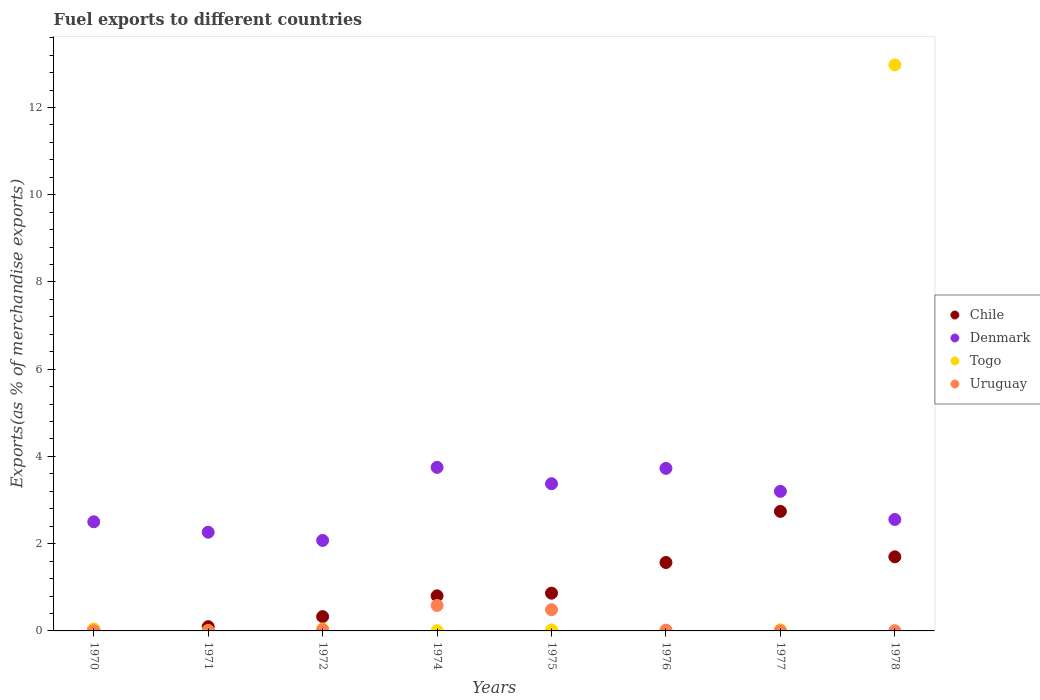How many different coloured dotlines are there?
Provide a succinct answer. 4. Is the number of dotlines equal to the number of legend labels?
Offer a terse response. Yes. What is the percentage of exports to different countries in Chile in 1977?
Offer a very short reply. 2.74. Across all years, what is the maximum percentage of exports to different countries in Chile?
Your response must be concise. 2.74. Across all years, what is the minimum percentage of exports to different countries in Togo?
Ensure brevity in your answer.  0. In which year was the percentage of exports to different countries in Uruguay maximum?
Offer a terse response. 1974. In which year was the percentage of exports to different countries in Chile minimum?
Give a very brief answer. 1970. What is the total percentage of exports to different countries in Togo in the graph?
Ensure brevity in your answer.  13.13. What is the difference between the percentage of exports to different countries in Uruguay in 1970 and that in 1971?
Offer a very short reply. -0. What is the difference between the percentage of exports to different countries in Denmark in 1971 and the percentage of exports to different countries in Togo in 1970?
Provide a short and direct response. 2.22. What is the average percentage of exports to different countries in Togo per year?
Make the answer very short. 1.64. In the year 1978, what is the difference between the percentage of exports to different countries in Chile and percentage of exports to different countries in Denmark?
Provide a succinct answer. -0.86. In how many years, is the percentage of exports to different countries in Denmark greater than 4 %?
Provide a succinct answer. 0. What is the ratio of the percentage of exports to different countries in Chile in 1971 to that in 1975?
Provide a short and direct response. 0.11. Is the percentage of exports to different countries in Togo in 1971 less than that in 1978?
Keep it short and to the point. Yes. Is the difference between the percentage of exports to different countries in Chile in 1970 and 1977 greater than the difference between the percentage of exports to different countries in Denmark in 1970 and 1977?
Make the answer very short. No. What is the difference between the highest and the second highest percentage of exports to different countries in Chile?
Ensure brevity in your answer.  1.04. What is the difference between the highest and the lowest percentage of exports to different countries in Chile?
Provide a short and direct response. 2.71. In how many years, is the percentage of exports to different countries in Denmark greater than the average percentage of exports to different countries in Denmark taken over all years?
Give a very brief answer. 4. Is it the case that in every year, the sum of the percentage of exports to different countries in Togo and percentage of exports to different countries in Uruguay  is greater than the sum of percentage of exports to different countries in Chile and percentage of exports to different countries in Denmark?
Provide a succinct answer. No. Does the percentage of exports to different countries in Denmark monotonically increase over the years?
Offer a very short reply. No. Is the percentage of exports to different countries in Togo strictly greater than the percentage of exports to different countries in Uruguay over the years?
Offer a very short reply. No. How many years are there in the graph?
Your answer should be compact. 8. Are the values on the major ticks of Y-axis written in scientific E-notation?
Provide a short and direct response. No. Does the graph contain grids?
Provide a succinct answer. No. How are the legend labels stacked?
Your answer should be very brief. Vertical. What is the title of the graph?
Offer a very short reply. Fuel exports to different countries. Does "Thailand" appear as one of the legend labels in the graph?
Keep it short and to the point. No. What is the label or title of the X-axis?
Offer a terse response. Years. What is the label or title of the Y-axis?
Your answer should be very brief. Exports(as % of merchandise exports). What is the Exports(as % of merchandise exports) in Chile in 1970?
Your response must be concise. 0.03. What is the Exports(as % of merchandise exports) of Denmark in 1970?
Offer a very short reply. 2.5. What is the Exports(as % of merchandise exports) in Togo in 1970?
Make the answer very short. 0.04. What is the Exports(as % of merchandise exports) in Uruguay in 1970?
Provide a short and direct response. 0. What is the Exports(as % of merchandise exports) in Chile in 1971?
Provide a succinct answer. 0.1. What is the Exports(as % of merchandise exports) of Denmark in 1971?
Your response must be concise. 2.26. What is the Exports(as % of merchandise exports) of Togo in 1971?
Keep it short and to the point. 0.01. What is the Exports(as % of merchandise exports) in Uruguay in 1971?
Your response must be concise. 0.01. What is the Exports(as % of merchandise exports) of Chile in 1972?
Keep it short and to the point. 0.33. What is the Exports(as % of merchandise exports) in Denmark in 1972?
Offer a very short reply. 2.07. What is the Exports(as % of merchandise exports) in Togo in 1972?
Provide a short and direct response. 0.05. What is the Exports(as % of merchandise exports) of Uruguay in 1972?
Ensure brevity in your answer.  0.03. What is the Exports(as % of merchandise exports) in Chile in 1974?
Give a very brief answer. 0.8. What is the Exports(as % of merchandise exports) in Denmark in 1974?
Offer a terse response. 3.75. What is the Exports(as % of merchandise exports) of Togo in 1974?
Offer a terse response. 0. What is the Exports(as % of merchandise exports) of Uruguay in 1974?
Provide a short and direct response. 0.58. What is the Exports(as % of merchandise exports) in Chile in 1975?
Offer a very short reply. 0.87. What is the Exports(as % of merchandise exports) of Denmark in 1975?
Provide a short and direct response. 3.37. What is the Exports(as % of merchandise exports) of Togo in 1975?
Offer a terse response. 0.02. What is the Exports(as % of merchandise exports) of Uruguay in 1975?
Make the answer very short. 0.49. What is the Exports(as % of merchandise exports) of Chile in 1976?
Provide a succinct answer. 1.57. What is the Exports(as % of merchandise exports) in Denmark in 1976?
Your response must be concise. 3.73. What is the Exports(as % of merchandise exports) in Togo in 1976?
Make the answer very short. 0. What is the Exports(as % of merchandise exports) of Uruguay in 1976?
Your answer should be compact. 0.02. What is the Exports(as % of merchandise exports) in Chile in 1977?
Offer a very short reply. 2.74. What is the Exports(as % of merchandise exports) of Denmark in 1977?
Ensure brevity in your answer.  3.2. What is the Exports(as % of merchandise exports) in Togo in 1977?
Keep it short and to the point. 0.03. What is the Exports(as % of merchandise exports) in Uruguay in 1977?
Make the answer very short. 0. What is the Exports(as % of merchandise exports) in Chile in 1978?
Offer a very short reply. 1.7. What is the Exports(as % of merchandise exports) of Denmark in 1978?
Keep it short and to the point. 2.56. What is the Exports(as % of merchandise exports) in Togo in 1978?
Make the answer very short. 12.98. What is the Exports(as % of merchandise exports) in Uruguay in 1978?
Keep it short and to the point. 0. Across all years, what is the maximum Exports(as % of merchandise exports) of Chile?
Give a very brief answer. 2.74. Across all years, what is the maximum Exports(as % of merchandise exports) in Denmark?
Ensure brevity in your answer.  3.75. Across all years, what is the maximum Exports(as % of merchandise exports) of Togo?
Your response must be concise. 12.98. Across all years, what is the maximum Exports(as % of merchandise exports) in Uruguay?
Offer a terse response. 0.58. Across all years, what is the minimum Exports(as % of merchandise exports) in Chile?
Your answer should be compact. 0.03. Across all years, what is the minimum Exports(as % of merchandise exports) of Denmark?
Give a very brief answer. 2.07. Across all years, what is the minimum Exports(as % of merchandise exports) of Togo?
Offer a very short reply. 0. Across all years, what is the minimum Exports(as % of merchandise exports) in Uruguay?
Give a very brief answer. 0. What is the total Exports(as % of merchandise exports) in Chile in the graph?
Offer a terse response. 8.14. What is the total Exports(as % of merchandise exports) in Denmark in the graph?
Offer a terse response. 23.45. What is the total Exports(as % of merchandise exports) of Togo in the graph?
Offer a terse response. 13.13. What is the total Exports(as % of merchandise exports) of Uruguay in the graph?
Your response must be concise. 1.13. What is the difference between the Exports(as % of merchandise exports) in Chile in 1970 and that in 1971?
Ensure brevity in your answer.  -0.06. What is the difference between the Exports(as % of merchandise exports) in Denmark in 1970 and that in 1971?
Provide a succinct answer. 0.24. What is the difference between the Exports(as % of merchandise exports) in Togo in 1970 and that in 1971?
Provide a succinct answer. 0.03. What is the difference between the Exports(as % of merchandise exports) in Uruguay in 1970 and that in 1971?
Ensure brevity in your answer.  -0. What is the difference between the Exports(as % of merchandise exports) in Chile in 1970 and that in 1972?
Offer a terse response. -0.29. What is the difference between the Exports(as % of merchandise exports) in Denmark in 1970 and that in 1972?
Your response must be concise. 0.43. What is the difference between the Exports(as % of merchandise exports) of Togo in 1970 and that in 1972?
Provide a short and direct response. -0. What is the difference between the Exports(as % of merchandise exports) in Uruguay in 1970 and that in 1972?
Offer a very short reply. -0.03. What is the difference between the Exports(as % of merchandise exports) in Chile in 1970 and that in 1974?
Offer a very short reply. -0.77. What is the difference between the Exports(as % of merchandise exports) in Denmark in 1970 and that in 1974?
Your answer should be compact. -1.25. What is the difference between the Exports(as % of merchandise exports) of Togo in 1970 and that in 1974?
Offer a very short reply. 0.04. What is the difference between the Exports(as % of merchandise exports) in Uruguay in 1970 and that in 1974?
Your answer should be very brief. -0.58. What is the difference between the Exports(as % of merchandise exports) in Chile in 1970 and that in 1975?
Your response must be concise. -0.83. What is the difference between the Exports(as % of merchandise exports) in Denmark in 1970 and that in 1975?
Keep it short and to the point. -0.87. What is the difference between the Exports(as % of merchandise exports) of Togo in 1970 and that in 1975?
Make the answer very short. 0.02. What is the difference between the Exports(as % of merchandise exports) of Uruguay in 1970 and that in 1975?
Keep it short and to the point. -0.48. What is the difference between the Exports(as % of merchandise exports) of Chile in 1970 and that in 1976?
Ensure brevity in your answer.  -1.53. What is the difference between the Exports(as % of merchandise exports) of Denmark in 1970 and that in 1976?
Offer a terse response. -1.22. What is the difference between the Exports(as % of merchandise exports) of Togo in 1970 and that in 1976?
Keep it short and to the point. 0.04. What is the difference between the Exports(as % of merchandise exports) in Uruguay in 1970 and that in 1976?
Your answer should be compact. -0.02. What is the difference between the Exports(as % of merchandise exports) of Chile in 1970 and that in 1977?
Provide a short and direct response. -2.71. What is the difference between the Exports(as % of merchandise exports) of Denmark in 1970 and that in 1977?
Offer a very short reply. -0.7. What is the difference between the Exports(as % of merchandise exports) of Togo in 1970 and that in 1977?
Keep it short and to the point. 0.02. What is the difference between the Exports(as % of merchandise exports) in Uruguay in 1970 and that in 1977?
Your answer should be very brief. -0. What is the difference between the Exports(as % of merchandise exports) in Chile in 1970 and that in 1978?
Offer a terse response. -1.67. What is the difference between the Exports(as % of merchandise exports) of Denmark in 1970 and that in 1978?
Offer a very short reply. -0.05. What is the difference between the Exports(as % of merchandise exports) in Togo in 1970 and that in 1978?
Keep it short and to the point. -12.93. What is the difference between the Exports(as % of merchandise exports) in Uruguay in 1970 and that in 1978?
Keep it short and to the point. -0. What is the difference between the Exports(as % of merchandise exports) of Chile in 1971 and that in 1972?
Your response must be concise. -0.23. What is the difference between the Exports(as % of merchandise exports) of Denmark in 1971 and that in 1972?
Offer a very short reply. 0.19. What is the difference between the Exports(as % of merchandise exports) of Togo in 1971 and that in 1972?
Provide a short and direct response. -0.04. What is the difference between the Exports(as % of merchandise exports) in Uruguay in 1971 and that in 1972?
Provide a succinct answer. -0.02. What is the difference between the Exports(as % of merchandise exports) in Chile in 1971 and that in 1974?
Keep it short and to the point. -0.71. What is the difference between the Exports(as % of merchandise exports) of Denmark in 1971 and that in 1974?
Make the answer very short. -1.49. What is the difference between the Exports(as % of merchandise exports) of Togo in 1971 and that in 1974?
Offer a terse response. 0. What is the difference between the Exports(as % of merchandise exports) of Uruguay in 1971 and that in 1974?
Your response must be concise. -0.58. What is the difference between the Exports(as % of merchandise exports) of Chile in 1971 and that in 1975?
Offer a very short reply. -0.77. What is the difference between the Exports(as % of merchandise exports) in Denmark in 1971 and that in 1975?
Provide a succinct answer. -1.11. What is the difference between the Exports(as % of merchandise exports) in Togo in 1971 and that in 1975?
Ensure brevity in your answer.  -0.01. What is the difference between the Exports(as % of merchandise exports) of Uruguay in 1971 and that in 1975?
Keep it short and to the point. -0.48. What is the difference between the Exports(as % of merchandise exports) in Chile in 1971 and that in 1976?
Ensure brevity in your answer.  -1.47. What is the difference between the Exports(as % of merchandise exports) in Denmark in 1971 and that in 1976?
Offer a terse response. -1.46. What is the difference between the Exports(as % of merchandise exports) of Togo in 1971 and that in 1976?
Provide a succinct answer. 0. What is the difference between the Exports(as % of merchandise exports) in Uruguay in 1971 and that in 1976?
Provide a short and direct response. -0.01. What is the difference between the Exports(as % of merchandise exports) of Chile in 1971 and that in 1977?
Make the answer very short. -2.64. What is the difference between the Exports(as % of merchandise exports) of Denmark in 1971 and that in 1977?
Keep it short and to the point. -0.94. What is the difference between the Exports(as % of merchandise exports) of Togo in 1971 and that in 1977?
Offer a terse response. -0.02. What is the difference between the Exports(as % of merchandise exports) of Uruguay in 1971 and that in 1977?
Offer a terse response. 0. What is the difference between the Exports(as % of merchandise exports) of Chile in 1971 and that in 1978?
Make the answer very short. -1.6. What is the difference between the Exports(as % of merchandise exports) in Denmark in 1971 and that in 1978?
Offer a terse response. -0.29. What is the difference between the Exports(as % of merchandise exports) of Togo in 1971 and that in 1978?
Offer a terse response. -12.97. What is the difference between the Exports(as % of merchandise exports) in Uruguay in 1971 and that in 1978?
Keep it short and to the point. 0. What is the difference between the Exports(as % of merchandise exports) in Chile in 1972 and that in 1974?
Ensure brevity in your answer.  -0.48. What is the difference between the Exports(as % of merchandise exports) of Denmark in 1972 and that in 1974?
Make the answer very short. -1.68. What is the difference between the Exports(as % of merchandise exports) of Togo in 1972 and that in 1974?
Ensure brevity in your answer.  0.04. What is the difference between the Exports(as % of merchandise exports) in Uruguay in 1972 and that in 1974?
Keep it short and to the point. -0.55. What is the difference between the Exports(as % of merchandise exports) of Chile in 1972 and that in 1975?
Offer a terse response. -0.54. What is the difference between the Exports(as % of merchandise exports) of Denmark in 1972 and that in 1975?
Make the answer very short. -1.3. What is the difference between the Exports(as % of merchandise exports) of Togo in 1972 and that in 1975?
Give a very brief answer. 0.02. What is the difference between the Exports(as % of merchandise exports) of Uruguay in 1972 and that in 1975?
Your response must be concise. -0.46. What is the difference between the Exports(as % of merchandise exports) in Chile in 1972 and that in 1976?
Give a very brief answer. -1.24. What is the difference between the Exports(as % of merchandise exports) in Denmark in 1972 and that in 1976?
Provide a short and direct response. -1.65. What is the difference between the Exports(as % of merchandise exports) in Togo in 1972 and that in 1976?
Your response must be concise. 0.04. What is the difference between the Exports(as % of merchandise exports) of Uruguay in 1972 and that in 1976?
Offer a very short reply. 0.01. What is the difference between the Exports(as % of merchandise exports) in Chile in 1972 and that in 1977?
Your response must be concise. -2.41. What is the difference between the Exports(as % of merchandise exports) in Denmark in 1972 and that in 1977?
Offer a terse response. -1.13. What is the difference between the Exports(as % of merchandise exports) in Togo in 1972 and that in 1977?
Your answer should be very brief. 0.02. What is the difference between the Exports(as % of merchandise exports) of Uruguay in 1972 and that in 1977?
Give a very brief answer. 0.03. What is the difference between the Exports(as % of merchandise exports) of Chile in 1972 and that in 1978?
Keep it short and to the point. -1.37. What is the difference between the Exports(as % of merchandise exports) in Denmark in 1972 and that in 1978?
Make the answer very short. -0.48. What is the difference between the Exports(as % of merchandise exports) in Togo in 1972 and that in 1978?
Your response must be concise. -12.93. What is the difference between the Exports(as % of merchandise exports) of Uruguay in 1972 and that in 1978?
Give a very brief answer. 0.02. What is the difference between the Exports(as % of merchandise exports) in Chile in 1974 and that in 1975?
Keep it short and to the point. -0.06. What is the difference between the Exports(as % of merchandise exports) of Denmark in 1974 and that in 1975?
Provide a short and direct response. 0.37. What is the difference between the Exports(as % of merchandise exports) in Togo in 1974 and that in 1975?
Your answer should be compact. -0.02. What is the difference between the Exports(as % of merchandise exports) in Uruguay in 1974 and that in 1975?
Offer a very short reply. 0.1. What is the difference between the Exports(as % of merchandise exports) of Chile in 1974 and that in 1976?
Ensure brevity in your answer.  -0.76. What is the difference between the Exports(as % of merchandise exports) in Denmark in 1974 and that in 1976?
Your response must be concise. 0.02. What is the difference between the Exports(as % of merchandise exports) of Togo in 1974 and that in 1976?
Keep it short and to the point. 0. What is the difference between the Exports(as % of merchandise exports) of Uruguay in 1974 and that in 1976?
Your answer should be very brief. 0.56. What is the difference between the Exports(as % of merchandise exports) in Chile in 1974 and that in 1977?
Give a very brief answer. -1.94. What is the difference between the Exports(as % of merchandise exports) in Denmark in 1974 and that in 1977?
Provide a succinct answer. 0.55. What is the difference between the Exports(as % of merchandise exports) of Togo in 1974 and that in 1977?
Your answer should be compact. -0.02. What is the difference between the Exports(as % of merchandise exports) of Uruguay in 1974 and that in 1977?
Provide a succinct answer. 0.58. What is the difference between the Exports(as % of merchandise exports) in Chile in 1974 and that in 1978?
Offer a terse response. -0.89. What is the difference between the Exports(as % of merchandise exports) of Denmark in 1974 and that in 1978?
Your answer should be compact. 1.19. What is the difference between the Exports(as % of merchandise exports) of Togo in 1974 and that in 1978?
Your answer should be very brief. -12.97. What is the difference between the Exports(as % of merchandise exports) in Uruguay in 1974 and that in 1978?
Keep it short and to the point. 0.58. What is the difference between the Exports(as % of merchandise exports) in Chile in 1975 and that in 1976?
Give a very brief answer. -0.7. What is the difference between the Exports(as % of merchandise exports) in Denmark in 1975 and that in 1976?
Keep it short and to the point. -0.35. What is the difference between the Exports(as % of merchandise exports) of Togo in 1975 and that in 1976?
Give a very brief answer. 0.02. What is the difference between the Exports(as % of merchandise exports) of Uruguay in 1975 and that in 1976?
Your response must be concise. 0.47. What is the difference between the Exports(as % of merchandise exports) of Chile in 1975 and that in 1977?
Your answer should be compact. -1.88. What is the difference between the Exports(as % of merchandise exports) in Denmark in 1975 and that in 1977?
Ensure brevity in your answer.  0.17. What is the difference between the Exports(as % of merchandise exports) in Togo in 1975 and that in 1977?
Your response must be concise. -0. What is the difference between the Exports(as % of merchandise exports) in Uruguay in 1975 and that in 1977?
Offer a terse response. 0.48. What is the difference between the Exports(as % of merchandise exports) of Chile in 1975 and that in 1978?
Make the answer very short. -0.83. What is the difference between the Exports(as % of merchandise exports) in Denmark in 1975 and that in 1978?
Make the answer very short. 0.82. What is the difference between the Exports(as % of merchandise exports) in Togo in 1975 and that in 1978?
Give a very brief answer. -12.96. What is the difference between the Exports(as % of merchandise exports) of Uruguay in 1975 and that in 1978?
Your answer should be compact. 0.48. What is the difference between the Exports(as % of merchandise exports) of Chile in 1976 and that in 1977?
Offer a very short reply. -1.17. What is the difference between the Exports(as % of merchandise exports) in Denmark in 1976 and that in 1977?
Provide a succinct answer. 0.53. What is the difference between the Exports(as % of merchandise exports) of Togo in 1976 and that in 1977?
Keep it short and to the point. -0.02. What is the difference between the Exports(as % of merchandise exports) of Uruguay in 1976 and that in 1977?
Make the answer very short. 0.02. What is the difference between the Exports(as % of merchandise exports) in Chile in 1976 and that in 1978?
Make the answer very short. -0.13. What is the difference between the Exports(as % of merchandise exports) in Denmark in 1976 and that in 1978?
Give a very brief answer. 1.17. What is the difference between the Exports(as % of merchandise exports) in Togo in 1976 and that in 1978?
Keep it short and to the point. -12.97. What is the difference between the Exports(as % of merchandise exports) in Uruguay in 1976 and that in 1978?
Your answer should be compact. 0.01. What is the difference between the Exports(as % of merchandise exports) in Chile in 1977 and that in 1978?
Your answer should be very brief. 1.04. What is the difference between the Exports(as % of merchandise exports) in Denmark in 1977 and that in 1978?
Give a very brief answer. 0.65. What is the difference between the Exports(as % of merchandise exports) of Togo in 1977 and that in 1978?
Offer a very short reply. -12.95. What is the difference between the Exports(as % of merchandise exports) in Uruguay in 1977 and that in 1978?
Provide a short and direct response. -0. What is the difference between the Exports(as % of merchandise exports) of Chile in 1970 and the Exports(as % of merchandise exports) of Denmark in 1971?
Offer a very short reply. -2.23. What is the difference between the Exports(as % of merchandise exports) in Chile in 1970 and the Exports(as % of merchandise exports) in Togo in 1971?
Make the answer very short. 0.03. What is the difference between the Exports(as % of merchandise exports) in Chile in 1970 and the Exports(as % of merchandise exports) in Uruguay in 1971?
Your response must be concise. 0.03. What is the difference between the Exports(as % of merchandise exports) of Denmark in 1970 and the Exports(as % of merchandise exports) of Togo in 1971?
Make the answer very short. 2.49. What is the difference between the Exports(as % of merchandise exports) of Denmark in 1970 and the Exports(as % of merchandise exports) of Uruguay in 1971?
Keep it short and to the point. 2.5. What is the difference between the Exports(as % of merchandise exports) in Togo in 1970 and the Exports(as % of merchandise exports) in Uruguay in 1971?
Keep it short and to the point. 0.04. What is the difference between the Exports(as % of merchandise exports) in Chile in 1970 and the Exports(as % of merchandise exports) in Denmark in 1972?
Make the answer very short. -2.04. What is the difference between the Exports(as % of merchandise exports) of Chile in 1970 and the Exports(as % of merchandise exports) of Togo in 1972?
Your response must be concise. -0.01. What is the difference between the Exports(as % of merchandise exports) in Chile in 1970 and the Exports(as % of merchandise exports) in Uruguay in 1972?
Provide a succinct answer. 0.01. What is the difference between the Exports(as % of merchandise exports) of Denmark in 1970 and the Exports(as % of merchandise exports) of Togo in 1972?
Keep it short and to the point. 2.46. What is the difference between the Exports(as % of merchandise exports) of Denmark in 1970 and the Exports(as % of merchandise exports) of Uruguay in 1972?
Your response must be concise. 2.47. What is the difference between the Exports(as % of merchandise exports) of Togo in 1970 and the Exports(as % of merchandise exports) of Uruguay in 1972?
Provide a short and direct response. 0.01. What is the difference between the Exports(as % of merchandise exports) of Chile in 1970 and the Exports(as % of merchandise exports) of Denmark in 1974?
Provide a succinct answer. -3.72. What is the difference between the Exports(as % of merchandise exports) of Chile in 1970 and the Exports(as % of merchandise exports) of Togo in 1974?
Provide a short and direct response. 0.03. What is the difference between the Exports(as % of merchandise exports) in Chile in 1970 and the Exports(as % of merchandise exports) in Uruguay in 1974?
Offer a very short reply. -0.55. What is the difference between the Exports(as % of merchandise exports) of Denmark in 1970 and the Exports(as % of merchandise exports) of Togo in 1974?
Your answer should be compact. 2.5. What is the difference between the Exports(as % of merchandise exports) in Denmark in 1970 and the Exports(as % of merchandise exports) in Uruguay in 1974?
Make the answer very short. 1.92. What is the difference between the Exports(as % of merchandise exports) of Togo in 1970 and the Exports(as % of merchandise exports) of Uruguay in 1974?
Provide a succinct answer. -0.54. What is the difference between the Exports(as % of merchandise exports) in Chile in 1970 and the Exports(as % of merchandise exports) in Denmark in 1975?
Offer a very short reply. -3.34. What is the difference between the Exports(as % of merchandise exports) in Chile in 1970 and the Exports(as % of merchandise exports) in Togo in 1975?
Your answer should be very brief. 0.01. What is the difference between the Exports(as % of merchandise exports) of Chile in 1970 and the Exports(as % of merchandise exports) of Uruguay in 1975?
Your response must be concise. -0.45. What is the difference between the Exports(as % of merchandise exports) in Denmark in 1970 and the Exports(as % of merchandise exports) in Togo in 1975?
Make the answer very short. 2.48. What is the difference between the Exports(as % of merchandise exports) in Denmark in 1970 and the Exports(as % of merchandise exports) in Uruguay in 1975?
Offer a very short reply. 2.02. What is the difference between the Exports(as % of merchandise exports) in Togo in 1970 and the Exports(as % of merchandise exports) in Uruguay in 1975?
Offer a terse response. -0.44. What is the difference between the Exports(as % of merchandise exports) of Chile in 1970 and the Exports(as % of merchandise exports) of Denmark in 1976?
Your response must be concise. -3.69. What is the difference between the Exports(as % of merchandise exports) of Chile in 1970 and the Exports(as % of merchandise exports) of Togo in 1976?
Your response must be concise. 0.03. What is the difference between the Exports(as % of merchandise exports) of Chile in 1970 and the Exports(as % of merchandise exports) of Uruguay in 1976?
Make the answer very short. 0.02. What is the difference between the Exports(as % of merchandise exports) of Denmark in 1970 and the Exports(as % of merchandise exports) of Togo in 1976?
Give a very brief answer. 2.5. What is the difference between the Exports(as % of merchandise exports) of Denmark in 1970 and the Exports(as % of merchandise exports) of Uruguay in 1976?
Give a very brief answer. 2.48. What is the difference between the Exports(as % of merchandise exports) of Togo in 1970 and the Exports(as % of merchandise exports) of Uruguay in 1976?
Make the answer very short. 0.02. What is the difference between the Exports(as % of merchandise exports) in Chile in 1970 and the Exports(as % of merchandise exports) in Denmark in 1977?
Make the answer very short. -3.17. What is the difference between the Exports(as % of merchandise exports) of Chile in 1970 and the Exports(as % of merchandise exports) of Togo in 1977?
Give a very brief answer. 0.01. What is the difference between the Exports(as % of merchandise exports) of Chile in 1970 and the Exports(as % of merchandise exports) of Uruguay in 1977?
Give a very brief answer. 0.03. What is the difference between the Exports(as % of merchandise exports) in Denmark in 1970 and the Exports(as % of merchandise exports) in Togo in 1977?
Your response must be concise. 2.48. What is the difference between the Exports(as % of merchandise exports) in Denmark in 1970 and the Exports(as % of merchandise exports) in Uruguay in 1977?
Provide a short and direct response. 2.5. What is the difference between the Exports(as % of merchandise exports) of Togo in 1970 and the Exports(as % of merchandise exports) of Uruguay in 1977?
Give a very brief answer. 0.04. What is the difference between the Exports(as % of merchandise exports) in Chile in 1970 and the Exports(as % of merchandise exports) in Denmark in 1978?
Give a very brief answer. -2.52. What is the difference between the Exports(as % of merchandise exports) in Chile in 1970 and the Exports(as % of merchandise exports) in Togo in 1978?
Keep it short and to the point. -12.94. What is the difference between the Exports(as % of merchandise exports) of Chile in 1970 and the Exports(as % of merchandise exports) of Uruguay in 1978?
Offer a terse response. 0.03. What is the difference between the Exports(as % of merchandise exports) in Denmark in 1970 and the Exports(as % of merchandise exports) in Togo in 1978?
Your answer should be compact. -10.48. What is the difference between the Exports(as % of merchandise exports) of Denmark in 1970 and the Exports(as % of merchandise exports) of Uruguay in 1978?
Offer a very short reply. 2.5. What is the difference between the Exports(as % of merchandise exports) in Togo in 1970 and the Exports(as % of merchandise exports) in Uruguay in 1978?
Your answer should be compact. 0.04. What is the difference between the Exports(as % of merchandise exports) in Chile in 1971 and the Exports(as % of merchandise exports) in Denmark in 1972?
Your response must be concise. -1.98. What is the difference between the Exports(as % of merchandise exports) of Chile in 1971 and the Exports(as % of merchandise exports) of Togo in 1972?
Provide a succinct answer. 0.05. What is the difference between the Exports(as % of merchandise exports) in Chile in 1971 and the Exports(as % of merchandise exports) in Uruguay in 1972?
Your answer should be very brief. 0.07. What is the difference between the Exports(as % of merchandise exports) in Denmark in 1971 and the Exports(as % of merchandise exports) in Togo in 1972?
Your answer should be very brief. 2.22. What is the difference between the Exports(as % of merchandise exports) in Denmark in 1971 and the Exports(as % of merchandise exports) in Uruguay in 1972?
Offer a very short reply. 2.23. What is the difference between the Exports(as % of merchandise exports) in Togo in 1971 and the Exports(as % of merchandise exports) in Uruguay in 1972?
Provide a short and direct response. -0.02. What is the difference between the Exports(as % of merchandise exports) of Chile in 1971 and the Exports(as % of merchandise exports) of Denmark in 1974?
Give a very brief answer. -3.65. What is the difference between the Exports(as % of merchandise exports) in Chile in 1971 and the Exports(as % of merchandise exports) in Togo in 1974?
Your answer should be compact. 0.09. What is the difference between the Exports(as % of merchandise exports) in Chile in 1971 and the Exports(as % of merchandise exports) in Uruguay in 1974?
Your response must be concise. -0.49. What is the difference between the Exports(as % of merchandise exports) of Denmark in 1971 and the Exports(as % of merchandise exports) of Togo in 1974?
Ensure brevity in your answer.  2.26. What is the difference between the Exports(as % of merchandise exports) of Denmark in 1971 and the Exports(as % of merchandise exports) of Uruguay in 1974?
Offer a terse response. 1.68. What is the difference between the Exports(as % of merchandise exports) in Togo in 1971 and the Exports(as % of merchandise exports) in Uruguay in 1974?
Offer a very short reply. -0.58. What is the difference between the Exports(as % of merchandise exports) of Chile in 1971 and the Exports(as % of merchandise exports) of Denmark in 1975?
Your answer should be compact. -3.28. What is the difference between the Exports(as % of merchandise exports) in Chile in 1971 and the Exports(as % of merchandise exports) in Togo in 1975?
Offer a very short reply. 0.08. What is the difference between the Exports(as % of merchandise exports) of Chile in 1971 and the Exports(as % of merchandise exports) of Uruguay in 1975?
Provide a succinct answer. -0.39. What is the difference between the Exports(as % of merchandise exports) of Denmark in 1971 and the Exports(as % of merchandise exports) of Togo in 1975?
Make the answer very short. 2.24. What is the difference between the Exports(as % of merchandise exports) of Denmark in 1971 and the Exports(as % of merchandise exports) of Uruguay in 1975?
Keep it short and to the point. 1.78. What is the difference between the Exports(as % of merchandise exports) in Togo in 1971 and the Exports(as % of merchandise exports) in Uruguay in 1975?
Your answer should be very brief. -0.48. What is the difference between the Exports(as % of merchandise exports) of Chile in 1971 and the Exports(as % of merchandise exports) of Denmark in 1976?
Offer a terse response. -3.63. What is the difference between the Exports(as % of merchandise exports) in Chile in 1971 and the Exports(as % of merchandise exports) in Togo in 1976?
Offer a terse response. 0.09. What is the difference between the Exports(as % of merchandise exports) in Chile in 1971 and the Exports(as % of merchandise exports) in Uruguay in 1976?
Provide a short and direct response. 0.08. What is the difference between the Exports(as % of merchandise exports) in Denmark in 1971 and the Exports(as % of merchandise exports) in Togo in 1976?
Offer a terse response. 2.26. What is the difference between the Exports(as % of merchandise exports) in Denmark in 1971 and the Exports(as % of merchandise exports) in Uruguay in 1976?
Give a very brief answer. 2.24. What is the difference between the Exports(as % of merchandise exports) of Togo in 1971 and the Exports(as % of merchandise exports) of Uruguay in 1976?
Provide a short and direct response. -0.01. What is the difference between the Exports(as % of merchandise exports) in Chile in 1971 and the Exports(as % of merchandise exports) in Denmark in 1977?
Give a very brief answer. -3.1. What is the difference between the Exports(as % of merchandise exports) in Chile in 1971 and the Exports(as % of merchandise exports) in Togo in 1977?
Provide a short and direct response. 0.07. What is the difference between the Exports(as % of merchandise exports) of Chile in 1971 and the Exports(as % of merchandise exports) of Uruguay in 1977?
Offer a very short reply. 0.09. What is the difference between the Exports(as % of merchandise exports) of Denmark in 1971 and the Exports(as % of merchandise exports) of Togo in 1977?
Provide a succinct answer. 2.24. What is the difference between the Exports(as % of merchandise exports) in Denmark in 1971 and the Exports(as % of merchandise exports) in Uruguay in 1977?
Ensure brevity in your answer.  2.26. What is the difference between the Exports(as % of merchandise exports) of Togo in 1971 and the Exports(as % of merchandise exports) of Uruguay in 1977?
Make the answer very short. 0. What is the difference between the Exports(as % of merchandise exports) of Chile in 1971 and the Exports(as % of merchandise exports) of Denmark in 1978?
Your response must be concise. -2.46. What is the difference between the Exports(as % of merchandise exports) in Chile in 1971 and the Exports(as % of merchandise exports) in Togo in 1978?
Offer a very short reply. -12.88. What is the difference between the Exports(as % of merchandise exports) in Chile in 1971 and the Exports(as % of merchandise exports) in Uruguay in 1978?
Offer a very short reply. 0.09. What is the difference between the Exports(as % of merchandise exports) of Denmark in 1971 and the Exports(as % of merchandise exports) of Togo in 1978?
Make the answer very short. -10.71. What is the difference between the Exports(as % of merchandise exports) of Denmark in 1971 and the Exports(as % of merchandise exports) of Uruguay in 1978?
Provide a short and direct response. 2.26. What is the difference between the Exports(as % of merchandise exports) in Togo in 1971 and the Exports(as % of merchandise exports) in Uruguay in 1978?
Give a very brief answer. 0. What is the difference between the Exports(as % of merchandise exports) of Chile in 1972 and the Exports(as % of merchandise exports) of Denmark in 1974?
Offer a very short reply. -3.42. What is the difference between the Exports(as % of merchandise exports) in Chile in 1972 and the Exports(as % of merchandise exports) in Togo in 1974?
Provide a succinct answer. 0.32. What is the difference between the Exports(as % of merchandise exports) in Chile in 1972 and the Exports(as % of merchandise exports) in Uruguay in 1974?
Your response must be concise. -0.26. What is the difference between the Exports(as % of merchandise exports) in Denmark in 1972 and the Exports(as % of merchandise exports) in Togo in 1974?
Provide a succinct answer. 2.07. What is the difference between the Exports(as % of merchandise exports) in Denmark in 1972 and the Exports(as % of merchandise exports) in Uruguay in 1974?
Your answer should be compact. 1.49. What is the difference between the Exports(as % of merchandise exports) of Togo in 1972 and the Exports(as % of merchandise exports) of Uruguay in 1974?
Your response must be concise. -0.54. What is the difference between the Exports(as % of merchandise exports) of Chile in 1972 and the Exports(as % of merchandise exports) of Denmark in 1975?
Keep it short and to the point. -3.05. What is the difference between the Exports(as % of merchandise exports) of Chile in 1972 and the Exports(as % of merchandise exports) of Togo in 1975?
Offer a very short reply. 0.31. What is the difference between the Exports(as % of merchandise exports) in Chile in 1972 and the Exports(as % of merchandise exports) in Uruguay in 1975?
Offer a terse response. -0.16. What is the difference between the Exports(as % of merchandise exports) of Denmark in 1972 and the Exports(as % of merchandise exports) of Togo in 1975?
Offer a terse response. 2.05. What is the difference between the Exports(as % of merchandise exports) in Denmark in 1972 and the Exports(as % of merchandise exports) in Uruguay in 1975?
Provide a succinct answer. 1.59. What is the difference between the Exports(as % of merchandise exports) in Togo in 1972 and the Exports(as % of merchandise exports) in Uruguay in 1975?
Provide a short and direct response. -0.44. What is the difference between the Exports(as % of merchandise exports) of Chile in 1972 and the Exports(as % of merchandise exports) of Denmark in 1976?
Ensure brevity in your answer.  -3.4. What is the difference between the Exports(as % of merchandise exports) in Chile in 1972 and the Exports(as % of merchandise exports) in Togo in 1976?
Your response must be concise. 0.32. What is the difference between the Exports(as % of merchandise exports) of Chile in 1972 and the Exports(as % of merchandise exports) of Uruguay in 1976?
Your answer should be compact. 0.31. What is the difference between the Exports(as % of merchandise exports) of Denmark in 1972 and the Exports(as % of merchandise exports) of Togo in 1976?
Give a very brief answer. 2.07. What is the difference between the Exports(as % of merchandise exports) of Denmark in 1972 and the Exports(as % of merchandise exports) of Uruguay in 1976?
Your answer should be very brief. 2.06. What is the difference between the Exports(as % of merchandise exports) of Togo in 1972 and the Exports(as % of merchandise exports) of Uruguay in 1976?
Ensure brevity in your answer.  0.03. What is the difference between the Exports(as % of merchandise exports) in Chile in 1972 and the Exports(as % of merchandise exports) in Denmark in 1977?
Ensure brevity in your answer.  -2.87. What is the difference between the Exports(as % of merchandise exports) in Chile in 1972 and the Exports(as % of merchandise exports) in Togo in 1977?
Make the answer very short. 0.3. What is the difference between the Exports(as % of merchandise exports) of Chile in 1972 and the Exports(as % of merchandise exports) of Uruguay in 1977?
Offer a very short reply. 0.33. What is the difference between the Exports(as % of merchandise exports) of Denmark in 1972 and the Exports(as % of merchandise exports) of Togo in 1977?
Provide a short and direct response. 2.05. What is the difference between the Exports(as % of merchandise exports) in Denmark in 1972 and the Exports(as % of merchandise exports) in Uruguay in 1977?
Provide a short and direct response. 2.07. What is the difference between the Exports(as % of merchandise exports) in Togo in 1972 and the Exports(as % of merchandise exports) in Uruguay in 1977?
Your response must be concise. 0.04. What is the difference between the Exports(as % of merchandise exports) in Chile in 1972 and the Exports(as % of merchandise exports) in Denmark in 1978?
Offer a very short reply. -2.23. What is the difference between the Exports(as % of merchandise exports) in Chile in 1972 and the Exports(as % of merchandise exports) in Togo in 1978?
Your answer should be very brief. -12.65. What is the difference between the Exports(as % of merchandise exports) in Chile in 1972 and the Exports(as % of merchandise exports) in Uruguay in 1978?
Your answer should be compact. 0.32. What is the difference between the Exports(as % of merchandise exports) of Denmark in 1972 and the Exports(as % of merchandise exports) of Togo in 1978?
Offer a very short reply. -10.9. What is the difference between the Exports(as % of merchandise exports) in Denmark in 1972 and the Exports(as % of merchandise exports) in Uruguay in 1978?
Offer a very short reply. 2.07. What is the difference between the Exports(as % of merchandise exports) in Togo in 1972 and the Exports(as % of merchandise exports) in Uruguay in 1978?
Provide a succinct answer. 0.04. What is the difference between the Exports(as % of merchandise exports) of Chile in 1974 and the Exports(as % of merchandise exports) of Denmark in 1975?
Provide a short and direct response. -2.57. What is the difference between the Exports(as % of merchandise exports) of Chile in 1974 and the Exports(as % of merchandise exports) of Togo in 1975?
Keep it short and to the point. 0.78. What is the difference between the Exports(as % of merchandise exports) in Chile in 1974 and the Exports(as % of merchandise exports) in Uruguay in 1975?
Offer a terse response. 0.32. What is the difference between the Exports(as % of merchandise exports) of Denmark in 1974 and the Exports(as % of merchandise exports) of Togo in 1975?
Your response must be concise. 3.73. What is the difference between the Exports(as % of merchandise exports) of Denmark in 1974 and the Exports(as % of merchandise exports) of Uruguay in 1975?
Offer a very short reply. 3.26. What is the difference between the Exports(as % of merchandise exports) in Togo in 1974 and the Exports(as % of merchandise exports) in Uruguay in 1975?
Offer a terse response. -0.48. What is the difference between the Exports(as % of merchandise exports) in Chile in 1974 and the Exports(as % of merchandise exports) in Denmark in 1976?
Offer a very short reply. -2.92. What is the difference between the Exports(as % of merchandise exports) in Chile in 1974 and the Exports(as % of merchandise exports) in Togo in 1976?
Provide a short and direct response. 0.8. What is the difference between the Exports(as % of merchandise exports) in Chile in 1974 and the Exports(as % of merchandise exports) in Uruguay in 1976?
Make the answer very short. 0.79. What is the difference between the Exports(as % of merchandise exports) of Denmark in 1974 and the Exports(as % of merchandise exports) of Togo in 1976?
Offer a terse response. 3.75. What is the difference between the Exports(as % of merchandise exports) of Denmark in 1974 and the Exports(as % of merchandise exports) of Uruguay in 1976?
Provide a succinct answer. 3.73. What is the difference between the Exports(as % of merchandise exports) in Togo in 1974 and the Exports(as % of merchandise exports) in Uruguay in 1976?
Provide a short and direct response. -0.01. What is the difference between the Exports(as % of merchandise exports) of Chile in 1974 and the Exports(as % of merchandise exports) of Denmark in 1977?
Keep it short and to the point. -2.4. What is the difference between the Exports(as % of merchandise exports) of Chile in 1974 and the Exports(as % of merchandise exports) of Togo in 1977?
Provide a short and direct response. 0.78. What is the difference between the Exports(as % of merchandise exports) of Chile in 1974 and the Exports(as % of merchandise exports) of Uruguay in 1977?
Make the answer very short. 0.8. What is the difference between the Exports(as % of merchandise exports) in Denmark in 1974 and the Exports(as % of merchandise exports) in Togo in 1977?
Offer a terse response. 3.72. What is the difference between the Exports(as % of merchandise exports) of Denmark in 1974 and the Exports(as % of merchandise exports) of Uruguay in 1977?
Provide a short and direct response. 3.75. What is the difference between the Exports(as % of merchandise exports) of Togo in 1974 and the Exports(as % of merchandise exports) of Uruguay in 1977?
Give a very brief answer. 0. What is the difference between the Exports(as % of merchandise exports) in Chile in 1974 and the Exports(as % of merchandise exports) in Denmark in 1978?
Your answer should be compact. -1.75. What is the difference between the Exports(as % of merchandise exports) in Chile in 1974 and the Exports(as % of merchandise exports) in Togo in 1978?
Provide a short and direct response. -12.17. What is the difference between the Exports(as % of merchandise exports) of Chile in 1974 and the Exports(as % of merchandise exports) of Uruguay in 1978?
Make the answer very short. 0.8. What is the difference between the Exports(as % of merchandise exports) in Denmark in 1974 and the Exports(as % of merchandise exports) in Togo in 1978?
Offer a terse response. -9.23. What is the difference between the Exports(as % of merchandise exports) of Denmark in 1974 and the Exports(as % of merchandise exports) of Uruguay in 1978?
Your answer should be compact. 3.75. What is the difference between the Exports(as % of merchandise exports) in Chile in 1975 and the Exports(as % of merchandise exports) in Denmark in 1976?
Provide a succinct answer. -2.86. What is the difference between the Exports(as % of merchandise exports) in Chile in 1975 and the Exports(as % of merchandise exports) in Togo in 1976?
Provide a short and direct response. 0.86. What is the difference between the Exports(as % of merchandise exports) of Chile in 1975 and the Exports(as % of merchandise exports) of Uruguay in 1976?
Your answer should be very brief. 0.85. What is the difference between the Exports(as % of merchandise exports) of Denmark in 1975 and the Exports(as % of merchandise exports) of Togo in 1976?
Your response must be concise. 3.37. What is the difference between the Exports(as % of merchandise exports) in Denmark in 1975 and the Exports(as % of merchandise exports) in Uruguay in 1976?
Offer a very short reply. 3.36. What is the difference between the Exports(as % of merchandise exports) of Togo in 1975 and the Exports(as % of merchandise exports) of Uruguay in 1976?
Your response must be concise. 0. What is the difference between the Exports(as % of merchandise exports) in Chile in 1975 and the Exports(as % of merchandise exports) in Denmark in 1977?
Keep it short and to the point. -2.33. What is the difference between the Exports(as % of merchandise exports) in Chile in 1975 and the Exports(as % of merchandise exports) in Togo in 1977?
Your response must be concise. 0.84. What is the difference between the Exports(as % of merchandise exports) in Chile in 1975 and the Exports(as % of merchandise exports) in Uruguay in 1977?
Offer a terse response. 0.86. What is the difference between the Exports(as % of merchandise exports) in Denmark in 1975 and the Exports(as % of merchandise exports) in Togo in 1977?
Make the answer very short. 3.35. What is the difference between the Exports(as % of merchandise exports) of Denmark in 1975 and the Exports(as % of merchandise exports) of Uruguay in 1977?
Offer a terse response. 3.37. What is the difference between the Exports(as % of merchandise exports) in Togo in 1975 and the Exports(as % of merchandise exports) in Uruguay in 1977?
Your response must be concise. 0.02. What is the difference between the Exports(as % of merchandise exports) of Chile in 1975 and the Exports(as % of merchandise exports) of Denmark in 1978?
Offer a very short reply. -1.69. What is the difference between the Exports(as % of merchandise exports) in Chile in 1975 and the Exports(as % of merchandise exports) in Togo in 1978?
Your answer should be compact. -12.11. What is the difference between the Exports(as % of merchandise exports) of Chile in 1975 and the Exports(as % of merchandise exports) of Uruguay in 1978?
Your answer should be very brief. 0.86. What is the difference between the Exports(as % of merchandise exports) in Denmark in 1975 and the Exports(as % of merchandise exports) in Togo in 1978?
Offer a very short reply. -9.6. What is the difference between the Exports(as % of merchandise exports) in Denmark in 1975 and the Exports(as % of merchandise exports) in Uruguay in 1978?
Your answer should be compact. 3.37. What is the difference between the Exports(as % of merchandise exports) in Togo in 1975 and the Exports(as % of merchandise exports) in Uruguay in 1978?
Your answer should be compact. 0.02. What is the difference between the Exports(as % of merchandise exports) of Chile in 1976 and the Exports(as % of merchandise exports) of Denmark in 1977?
Ensure brevity in your answer.  -1.63. What is the difference between the Exports(as % of merchandise exports) of Chile in 1976 and the Exports(as % of merchandise exports) of Togo in 1977?
Your response must be concise. 1.54. What is the difference between the Exports(as % of merchandise exports) in Chile in 1976 and the Exports(as % of merchandise exports) in Uruguay in 1977?
Your answer should be compact. 1.57. What is the difference between the Exports(as % of merchandise exports) of Denmark in 1976 and the Exports(as % of merchandise exports) of Togo in 1977?
Offer a very short reply. 3.7. What is the difference between the Exports(as % of merchandise exports) of Denmark in 1976 and the Exports(as % of merchandise exports) of Uruguay in 1977?
Provide a short and direct response. 3.72. What is the difference between the Exports(as % of merchandise exports) of Togo in 1976 and the Exports(as % of merchandise exports) of Uruguay in 1977?
Provide a short and direct response. 0. What is the difference between the Exports(as % of merchandise exports) of Chile in 1976 and the Exports(as % of merchandise exports) of Denmark in 1978?
Your response must be concise. -0.99. What is the difference between the Exports(as % of merchandise exports) of Chile in 1976 and the Exports(as % of merchandise exports) of Togo in 1978?
Offer a terse response. -11.41. What is the difference between the Exports(as % of merchandise exports) of Chile in 1976 and the Exports(as % of merchandise exports) of Uruguay in 1978?
Offer a terse response. 1.56. What is the difference between the Exports(as % of merchandise exports) in Denmark in 1976 and the Exports(as % of merchandise exports) in Togo in 1978?
Your response must be concise. -9.25. What is the difference between the Exports(as % of merchandise exports) of Denmark in 1976 and the Exports(as % of merchandise exports) of Uruguay in 1978?
Offer a very short reply. 3.72. What is the difference between the Exports(as % of merchandise exports) in Togo in 1976 and the Exports(as % of merchandise exports) in Uruguay in 1978?
Ensure brevity in your answer.  -0. What is the difference between the Exports(as % of merchandise exports) in Chile in 1977 and the Exports(as % of merchandise exports) in Denmark in 1978?
Make the answer very short. 0.19. What is the difference between the Exports(as % of merchandise exports) of Chile in 1977 and the Exports(as % of merchandise exports) of Togo in 1978?
Provide a succinct answer. -10.24. What is the difference between the Exports(as % of merchandise exports) of Chile in 1977 and the Exports(as % of merchandise exports) of Uruguay in 1978?
Your answer should be compact. 2.74. What is the difference between the Exports(as % of merchandise exports) of Denmark in 1977 and the Exports(as % of merchandise exports) of Togo in 1978?
Ensure brevity in your answer.  -9.78. What is the difference between the Exports(as % of merchandise exports) in Denmark in 1977 and the Exports(as % of merchandise exports) in Uruguay in 1978?
Your answer should be very brief. 3.2. What is the difference between the Exports(as % of merchandise exports) of Togo in 1977 and the Exports(as % of merchandise exports) of Uruguay in 1978?
Provide a succinct answer. 0.02. What is the average Exports(as % of merchandise exports) in Chile per year?
Offer a very short reply. 1.02. What is the average Exports(as % of merchandise exports) of Denmark per year?
Ensure brevity in your answer.  2.93. What is the average Exports(as % of merchandise exports) in Togo per year?
Your answer should be compact. 1.64. What is the average Exports(as % of merchandise exports) of Uruguay per year?
Your response must be concise. 0.14. In the year 1970, what is the difference between the Exports(as % of merchandise exports) of Chile and Exports(as % of merchandise exports) of Denmark?
Give a very brief answer. -2.47. In the year 1970, what is the difference between the Exports(as % of merchandise exports) in Chile and Exports(as % of merchandise exports) in Togo?
Provide a short and direct response. -0.01. In the year 1970, what is the difference between the Exports(as % of merchandise exports) in Chile and Exports(as % of merchandise exports) in Uruguay?
Provide a short and direct response. 0.03. In the year 1970, what is the difference between the Exports(as % of merchandise exports) in Denmark and Exports(as % of merchandise exports) in Togo?
Your response must be concise. 2.46. In the year 1970, what is the difference between the Exports(as % of merchandise exports) in Denmark and Exports(as % of merchandise exports) in Uruguay?
Offer a very short reply. 2.5. In the year 1970, what is the difference between the Exports(as % of merchandise exports) in Togo and Exports(as % of merchandise exports) in Uruguay?
Offer a very short reply. 0.04. In the year 1971, what is the difference between the Exports(as % of merchandise exports) in Chile and Exports(as % of merchandise exports) in Denmark?
Make the answer very short. -2.17. In the year 1971, what is the difference between the Exports(as % of merchandise exports) in Chile and Exports(as % of merchandise exports) in Togo?
Offer a terse response. 0.09. In the year 1971, what is the difference between the Exports(as % of merchandise exports) of Chile and Exports(as % of merchandise exports) of Uruguay?
Give a very brief answer. 0.09. In the year 1971, what is the difference between the Exports(as % of merchandise exports) in Denmark and Exports(as % of merchandise exports) in Togo?
Make the answer very short. 2.26. In the year 1971, what is the difference between the Exports(as % of merchandise exports) of Denmark and Exports(as % of merchandise exports) of Uruguay?
Give a very brief answer. 2.26. In the year 1971, what is the difference between the Exports(as % of merchandise exports) in Togo and Exports(as % of merchandise exports) in Uruguay?
Provide a succinct answer. 0. In the year 1972, what is the difference between the Exports(as % of merchandise exports) in Chile and Exports(as % of merchandise exports) in Denmark?
Make the answer very short. -1.75. In the year 1972, what is the difference between the Exports(as % of merchandise exports) of Chile and Exports(as % of merchandise exports) of Togo?
Ensure brevity in your answer.  0.28. In the year 1972, what is the difference between the Exports(as % of merchandise exports) of Chile and Exports(as % of merchandise exports) of Uruguay?
Offer a very short reply. 0.3. In the year 1972, what is the difference between the Exports(as % of merchandise exports) in Denmark and Exports(as % of merchandise exports) in Togo?
Make the answer very short. 2.03. In the year 1972, what is the difference between the Exports(as % of merchandise exports) of Denmark and Exports(as % of merchandise exports) of Uruguay?
Provide a succinct answer. 2.05. In the year 1972, what is the difference between the Exports(as % of merchandise exports) in Togo and Exports(as % of merchandise exports) in Uruguay?
Make the answer very short. 0.02. In the year 1974, what is the difference between the Exports(as % of merchandise exports) in Chile and Exports(as % of merchandise exports) in Denmark?
Ensure brevity in your answer.  -2.95. In the year 1974, what is the difference between the Exports(as % of merchandise exports) in Chile and Exports(as % of merchandise exports) in Togo?
Offer a terse response. 0.8. In the year 1974, what is the difference between the Exports(as % of merchandise exports) of Chile and Exports(as % of merchandise exports) of Uruguay?
Provide a short and direct response. 0.22. In the year 1974, what is the difference between the Exports(as % of merchandise exports) of Denmark and Exports(as % of merchandise exports) of Togo?
Provide a short and direct response. 3.75. In the year 1974, what is the difference between the Exports(as % of merchandise exports) in Denmark and Exports(as % of merchandise exports) in Uruguay?
Your response must be concise. 3.17. In the year 1974, what is the difference between the Exports(as % of merchandise exports) of Togo and Exports(as % of merchandise exports) of Uruguay?
Your answer should be very brief. -0.58. In the year 1975, what is the difference between the Exports(as % of merchandise exports) in Chile and Exports(as % of merchandise exports) in Denmark?
Make the answer very short. -2.51. In the year 1975, what is the difference between the Exports(as % of merchandise exports) in Chile and Exports(as % of merchandise exports) in Togo?
Your response must be concise. 0.84. In the year 1975, what is the difference between the Exports(as % of merchandise exports) of Chile and Exports(as % of merchandise exports) of Uruguay?
Your answer should be compact. 0.38. In the year 1975, what is the difference between the Exports(as % of merchandise exports) of Denmark and Exports(as % of merchandise exports) of Togo?
Make the answer very short. 3.35. In the year 1975, what is the difference between the Exports(as % of merchandise exports) of Denmark and Exports(as % of merchandise exports) of Uruguay?
Provide a short and direct response. 2.89. In the year 1975, what is the difference between the Exports(as % of merchandise exports) of Togo and Exports(as % of merchandise exports) of Uruguay?
Your response must be concise. -0.46. In the year 1976, what is the difference between the Exports(as % of merchandise exports) of Chile and Exports(as % of merchandise exports) of Denmark?
Your answer should be very brief. -2.16. In the year 1976, what is the difference between the Exports(as % of merchandise exports) in Chile and Exports(as % of merchandise exports) in Togo?
Ensure brevity in your answer.  1.57. In the year 1976, what is the difference between the Exports(as % of merchandise exports) in Chile and Exports(as % of merchandise exports) in Uruguay?
Make the answer very short. 1.55. In the year 1976, what is the difference between the Exports(as % of merchandise exports) of Denmark and Exports(as % of merchandise exports) of Togo?
Provide a short and direct response. 3.72. In the year 1976, what is the difference between the Exports(as % of merchandise exports) of Denmark and Exports(as % of merchandise exports) of Uruguay?
Provide a succinct answer. 3.71. In the year 1976, what is the difference between the Exports(as % of merchandise exports) of Togo and Exports(as % of merchandise exports) of Uruguay?
Offer a very short reply. -0.02. In the year 1977, what is the difference between the Exports(as % of merchandise exports) of Chile and Exports(as % of merchandise exports) of Denmark?
Keep it short and to the point. -0.46. In the year 1977, what is the difference between the Exports(as % of merchandise exports) of Chile and Exports(as % of merchandise exports) of Togo?
Keep it short and to the point. 2.72. In the year 1977, what is the difference between the Exports(as % of merchandise exports) of Chile and Exports(as % of merchandise exports) of Uruguay?
Your response must be concise. 2.74. In the year 1977, what is the difference between the Exports(as % of merchandise exports) in Denmark and Exports(as % of merchandise exports) in Togo?
Provide a succinct answer. 3.17. In the year 1977, what is the difference between the Exports(as % of merchandise exports) in Denmark and Exports(as % of merchandise exports) in Uruguay?
Your response must be concise. 3.2. In the year 1977, what is the difference between the Exports(as % of merchandise exports) in Togo and Exports(as % of merchandise exports) in Uruguay?
Provide a short and direct response. 0.02. In the year 1978, what is the difference between the Exports(as % of merchandise exports) of Chile and Exports(as % of merchandise exports) of Denmark?
Provide a succinct answer. -0.86. In the year 1978, what is the difference between the Exports(as % of merchandise exports) in Chile and Exports(as % of merchandise exports) in Togo?
Your response must be concise. -11.28. In the year 1978, what is the difference between the Exports(as % of merchandise exports) in Chile and Exports(as % of merchandise exports) in Uruguay?
Make the answer very short. 1.69. In the year 1978, what is the difference between the Exports(as % of merchandise exports) of Denmark and Exports(as % of merchandise exports) of Togo?
Ensure brevity in your answer.  -10.42. In the year 1978, what is the difference between the Exports(as % of merchandise exports) of Denmark and Exports(as % of merchandise exports) of Uruguay?
Your answer should be very brief. 2.55. In the year 1978, what is the difference between the Exports(as % of merchandise exports) in Togo and Exports(as % of merchandise exports) in Uruguay?
Make the answer very short. 12.97. What is the ratio of the Exports(as % of merchandise exports) of Chile in 1970 to that in 1971?
Your response must be concise. 0.35. What is the ratio of the Exports(as % of merchandise exports) of Denmark in 1970 to that in 1971?
Provide a short and direct response. 1.11. What is the ratio of the Exports(as % of merchandise exports) in Togo in 1970 to that in 1971?
Provide a succinct answer. 5.61. What is the ratio of the Exports(as % of merchandise exports) in Uruguay in 1970 to that in 1971?
Provide a succinct answer. 0.4. What is the ratio of the Exports(as % of merchandise exports) in Chile in 1970 to that in 1972?
Give a very brief answer. 0.1. What is the ratio of the Exports(as % of merchandise exports) in Denmark in 1970 to that in 1972?
Your answer should be very brief. 1.21. What is the ratio of the Exports(as % of merchandise exports) of Togo in 1970 to that in 1972?
Your answer should be compact. 0.93. What is the ratio of the Exports(as % of merchandise exports) of Uruguay in 1970 to that in 1972?
Provide a succinct answer. 0.07. What is the ratio of the Exports(as % of merchandise exports) of Chile in 1970 to that in 1974?
Your answer should be very brief. 0.04. What is the ratio of the Exports(as % of merchandise exports) of Denmark in 1970 to that in 1974?
Your response must be concise. 0.67. What is the ratio of the Exports(as % of merchandise exports) of Togo in 1970 to that in 1974?
Your answer should be very brief. 9.64. What is the ratio of the Exports(as % of merchandise exports) of Uruguay in 1970 to that in 1974?
Make the answer very short. 0. What is the ratio of the Exports(as % of merchandise exports) in Chile in 1970 to that in 1975?
Offer a terse response. 0.04. What is the ratio of the Exports(as % of merchandise exports) in Denmark in 1970 to that in 1975?
Keep it short and to the point. 0.74. What is the ratio of the Exports(as % of merchandise exports) in Togo in 1970 to that in 1975?
Your answer should be very brief. 1.92. What is the ratio of the Exports(as % of merchandise exports) in Uruguay in 1970 to that in 1975?
Your answer should be very brief. 0. What is the ratio of the Exports(as % of merchandise exports) in Chile in 1970 to that in 1976?
Your answer should be very brief. 0.02. What is the ratio of the Exports(as % of merchandise exports) of Denmark in 1970 to that in 1976?
Your response must be concise. 0.67. What is the ratio of the Exports(as % of merchandise exports) in Togo in 1970 to that in 1976?
Your answer should be very brief. 13.61. What is the ratio of the Exports(as % of merchandise exports) in Uruguay in 1970 to that in 1976?
Your answer should be compact. 0.11. What is the ratio of the Exports(as % of merchandise exports) of Chile in 1970 to that in 1977?
Offer a very short reply. 0.01. What is the ratio of the Exports(as % of merchandise exports) of Denmark in 1970 to that in 1977?
Give a very brief answer. 0.78. What is the ratio of the Exports(as % of merchandise exports) in Togo in 1970 to that in 1977?
Provide a succinct answer. 1.67. What is the ratio of the Exports(as % of merchandise exports) of Uruguay in 1970 to that in 1977?
Provide a succinct answer. 0.74. What is the ratio of the Exports(as % of merchandise exports) in Chile in 1970 to that in 1978?
Provide a succinct answer. 0.02. What is the ratio of the Exports(as % of merchandise exports) in Denmark in 1970 to that in 1978?
Offer a very short reply. 0.98. What is the ratio of the Exports(as % of merchandise exports) in Togo in 1970 to that in 1978?
Provide a succinct answer. 0. What is the ratio of the Exports(as % of merchandise exports) of Uruguay in 1970 to that in 1978?
Provide a succinct answer. 0.51. What is the ratio of the Exports(as % of merchandise exports) of Chile in 1971 to that in 1972?
Offer a very short reply. 0.3. What is the ratio of the Exports(as % of merchandise exports) of Denmark in 1971 to that in 1972?
Ensure brevity in your answer.  1.09. What is the ratio of the Exports(as % of merchandise exports) of Togo in 1971 to that in 1972?
Provide a short and direct response. 0.17. What is the ratio of the Exports(as % of merchandise exports) of Uruguay in 1971 to that in 1972?
Your answer should be compact. 0.19. What is the ratio of the Exports(as % of merchandise exports) in Chile in 1971 to that in 1974?
Your answer should be compact. 0.12. What is the ratio of the Exports(as % of merchandise exports) in Denmark in 1971 to that in 1974?
Give a very brief answer. 0.6. What is the ratio of the Exports(as % of merchandise exports) of Togo in 1971 to that in 1974?
Provide a succinct answer. 1.72. What is the ratio of the Exports(as % of merchandise exports) in Uruguay in 1971 to that in 1974?
Offer a terse response. 0.01. What is the ratio of the Exports(as % of merchandise exports) in Chile in 1971 to that in 1975?
Ensure brevity in your answer.  0.11. What is the ratio of the Exports(as % of merchandise exports) of Denmark in 1971 to that in 1975?
Make the answer very short. 0.67. What is the ratio of the Exports(as % of merchandise exports) of Togo in 1971 to that in 1975?
Your answer should be compact. 0.34. What is the ratio of the Exports(as % of merchandise exports) of Uruguay in 1971 to that in 1975?
Provide a succinct answer. 0.01. What is the ratio of the Exports(as % of merchandise exports) in Chile in 1971 to that in 1976?
Make the answer very short. 0.06. What is the ratio of the Exports(as % of merchandise exports) in Denmark in 1971 to that in 1976?
Give a very brief answer. 0.61. What is the ratio of the Exports(as % of merchandise exports) in Togo in 1971 to that in 1976?
Keep it short and to the point. 2.42. What is the ratio of the Exports(as % of merchandise exports) of Uruguay in 1971 to that in 1976?
Offer a very short reply. 0.29. What is the ratio of the Exports(as % of merchandise exports) of Chile in 1971 to that in 1977?
Your answer should be very brief. 0.04. What is the ratio of the Exports(as % of merchandise exports) of Denmark in 1971 to that in 1977?
Provide a succinct answer. 0.71. What is the ratio of the Exports(as % of merchandise exports) of Togo in 1971 to that in 1977?
Provide a succinct answer. 0.3. What is the ratio of the Exports(as % of merchandise exports) in Uruguay in 1971 to that in 1977?
Offer a terse response. 1.87. What is the ratio of the Exports(as % of merchandise exports) of Chile in 1971 to that in 1978?
Your answer should be compact. 0.06. What is the ratio of the Exports(as % of merchandise exports) in Denmark in 1971 to that in 1978?
Offer a very short reply. 0.89. What is the ratio of the Exports(as % of merchandise exports) of Togo in 1971 to that in 1978?
Keep it short and to the point. 0. What is the ratio of the Exports(as % of merchandise exports) of Uruguay in 1971 to that in 1978?
Ensure brevity in your answer.  1.3. What is the ratio of the Exports(as % of merchandise exports) of Chile in 1972 to that in 1974?
Provide a succinct answer. 0.41. What is the ratio of the Exports(as % of merchandise exports) of Denmark in 1972 to that in 1974?
Give a very brief answer. 0.55. What is the ratio of the Exports(as % of merchandise exports) of Togo in 1972 to that in 1974?
Keep it short and to the point. 10.37. What is the ratio of the Exports(as % of merchandise exports) in Uruguay in 1972 to that in 1974?
Make the answer very short. 0.05. What is the ratio of the Exports(as % of merchandise exports) in Chile in 1972 to that in 1975?
Keep it short and to the point. 0.38. What is the ratio of the Exports(as % of merchandise exports) of Denmark in 1972 to that in 1975?
Offer a very short reply. 0.61. What is the ratio of the Exports(as % of merchandise exports) in Togo in 1972 to that in 1975?
Your answer should be very brief. 2.07. What is the ratio of the Exports(as % of merchandise exports) in Uruguay in 1972 to that in 1975?
Your response must be concise. 0.06. What is the ratio of the Exports(as % of merchandise exports) in Chile in 1972 to that in 1976?
Provide a succinct answer. 0.21. What is the ratio of the Exports(as % of merchandise exports) of Denmark in 1972 to that in 1976?
Give a very brief answer. 0.56. What is the ratio of the Exports(as % of merchandise exports) of Togo in 1972 to that in 1976?
Give a very brief answer. 14.64. What is the ratio of the Exports(as % of merchandise exports) of Uruguay in 1972 to that in 1976?
Your answer should be very brief. 1.56. What is the ratio of the Exports(as % of merchandise exports) in Chile in 1972 to that in 1977?
Offer a terse response. 0.12. What is the ratio of the Exports(as % of merchandise exports) of Denmark in 1972 to that in 1977?
Make the answer very short. 0.65. What is the ratio of the Exports(as % of merchandise exports) in Togo in 1972 to that in 1977?
Your answer should be compact. 1.8. What is the ratio of the Exports(as % of merchandise exports) in Uruguay in 1972 to that in 1977?
Keep it short and to the point. 10.11. What is the ratio of the Exports(as % of merchandise exports) in Chile in 1972 to that in 1978?
Provide a short and direct response. 0.19. What is the ratio of the Exports(as % of merchandise exports) of Denmark in 1972 to that in 1978?
Provide a short and direct response. 0.81. What is the ratio of the Exports(as % of merchandise exports) of Togo in 1972 to that in 1978?
Provide a short and direct response. 0. What is the ratio of the Exports(as % of merchandise exports) in Uruguay in 1972 to that in 1978?
Give a very brief answer. 7.01. What is the ratio of the Exports(as % of merchandise exports) in Chile in 1974 to that in 1975?
Offer a very short reply. 0.93. What is the ratio of the Exports(as % of merchandise exports) in Denmark in 1974 to that in 1975?
Provide a succinct answer. 1.11. What is the ratio of the Exports(as % of merchandise exports) of Togo in 1974 to that in 1975?
Keep it short and to the point. 0.2. What is the ratio of the Exports(as % of merchandise exports) of Uruguay in 1974 to that in 1975?
Your response must be concise. 1.2. What is the ratio of the Exports(as % of merchandise exports) in Chile in 1974 to that in 1976?
Give a very brief answer. 0.51. What is the ratio of the Exports(as % of merchandise exports) of Denmark in 1974 to that in 1976?
Offer a terse response. 1.01. What is the ratio of the Exports(as % of merchandise exports) in Togo in 1974 to that in 1976?
Ensure brevity in your answer.  1.41. What is the ratio of the Exports(as % of merchandise exports) of Uruguay in 1974 to that in 1976?
Keep it short and to the point. 31.5. What is the ratio of the Exports(as % of merchandise exports) of Chile in 1974 to that in 1977?
Your answer should be very brief. 0.29. What is the ratio of the Exports(as % of merchandise exports) in Denmark in 1974 to that in 1977?
Make the answer very short. 1.17. What is the ratio of the Exports(as % of merchandise exports) of Togo in 1974 to that in 1977?
Provide a short and direct response. 0.17. What is the ratio of the Exports(as % of merchandise exports) in Uruguay in 1974 to that in 1977?
Your response must be concise. 204.59. What is the ratio of the Exports(as % of merchandise exports) in Chile in 1974 to that in 1978?
Provide a short and direct response. 0.47. What is the ratio of the Exports(as % of merchandise exports) of Denmark in 1974 to that in 1978?
Ensure brevity in your answer.  1.47. What is the ratio of the Exports(as % of merchandise exports) of Togo in 1974 to that in 1978?
Make the answer very short. 0. What is the ratio of the Exports(as % of merchandise exports) of Uruguay in 1974 to that in 1978?
Keep it short and to the point. 141.8. What is the ratio of the Exports(as % of merchandise exports) in Chile in 1975 to that in 1976?
Provide a short and direct response. 0.55. What is the ratio of the Exports(as % of merchandise exports) in Denmark in 1975 to that in 1976?
Provide a succinct answer. 0.91. What is the ratio of the Exports(as % of merchandise exports) of Togo in 1975 to that in 1976?
Offer a terse response. 7.08. What is the ratio of the Exports(as % of merchandise exports) in Uruguay in 1975 to that in 1976?
Ensure brevity in your answer.  26.26. What is the ratio of the Exports(as % of merchandise exports) of Chile in 1975 to that in 1977?
Ensure brevity in your answer.  0.32. What is the ratio of the Exports(as % of merchandise exports) in Denmark in 1975 to that in 1977?
Provide a succinct answer. 1.05. What is the ratio of the Exports(as % of merchandise exports) in Togo in 1975 to that in 1977?
Keep it short and to the point. 0.87. What is the ratio of the Exports(as % of merchandise exports) in Uruguay in 1975 to that in 1977?
Provide a succinct answer. 170.57. What is the ratio of the Exports(as % of merchandise exports) of Chile in 1975 to that in 1978?
Offer a very short reply. 0.51. What is the ratio of the Exports(as % of merchandise exports) of Denmark in 1975 to that in 1978?
Provide a short and direct response. 1.32. What is the ratio of the Exports(as % of merchandise exports) in Togo in 1975 to that in 1978?
Give a very brief answer. 0. What is the ratio of the Exports(as % of merchandise exports) in Uruguay in 1975 to that in 1978?
Give a very brief answer. 118.22. What is the ratio of the Exports(as % of merchandise exports) in Chile in 1976 to that in 1977?
Give a very brief answer. 0.57. What is the ratio of the Exports(as % of merchandise exports) of Denmark in 1976 to that in 1977?
Your answer should be compact. 1.16. What is the ratio of the Exports(as % of merchandise exports) of Togo in 1976 to that in 1977?
Make the answer very short. 0.12. What is the ratio of the Exports(as % of merchandise exports) of Uruguay in 1976 to that in 1977?
Ensure brevity in your answer.  6.49. What is the ratio of the Exports(as % of merchandise exports) in Chile in 1976 to that in 1978?
Your response must be concise. 0.92. What is the ratio of the Exports(as % of merchandise exports) in Denmark in 1976 to that in 1978?
Your response must be concise. 1.46. What is the ratio of the Exports(as % of merchandise exports) in Uruguay in 1976 to that in 1978?
Offer a terse response. 4.5. What is the ratio of the Exports(as % of merchandise exports) of Chile in 1977 to that in 1978?
Your response must be concise. 1.61. What is the ratio of the Exports(as % of merchandise exports) in Denmark in 1977 to that in 1978?
Provide a short and direct response. 1.25. What is the ratio of the Exports(as % of merchandise exports) of Togo in 1977 to that in 1978?
Your answer should be very brief. 0. What is the ratio of the Exports(as % of merchandise exports) of Uruguay in 1977 to that in 1978?
Your answer should be very brief. 0.69. What is the difference between the highest and the second highest Exports(as % of merchandise exports) in Chile?
Provide a short and direct response. 1.04. What is the difference between the highest and the second highest Exports(as % of merchandise exports) of Denmark?
Make the answer very short. 0.02. What is the difference between the highest and the second highest Exports(as % of merchandise exports) of Togo?
Give a very brief answer. 12.93. What is the difference between the highest and the second highest Exports(as % of merchandise exports) in Uruguay?
Give a very brief answer. 0.1. What is the difference between the highest and the lowest Exports(as % of merchandise exports) of Chile?
Provide a succinct answer. 2.71. What is the difference between the highest and the lowest Exports(as % of merchandise exports) of Denmark?
Your answer should be compact. 1.68. What is the difference between the highest and the lowest Exports(as % of merchandise exports) of Togo?
Give a very brief answer. 12.97. What is the difference between the highest and the lowest Exports(as % of merchandise exports) in Uruguay?
Ensure brevity in your answer.  0.58. 